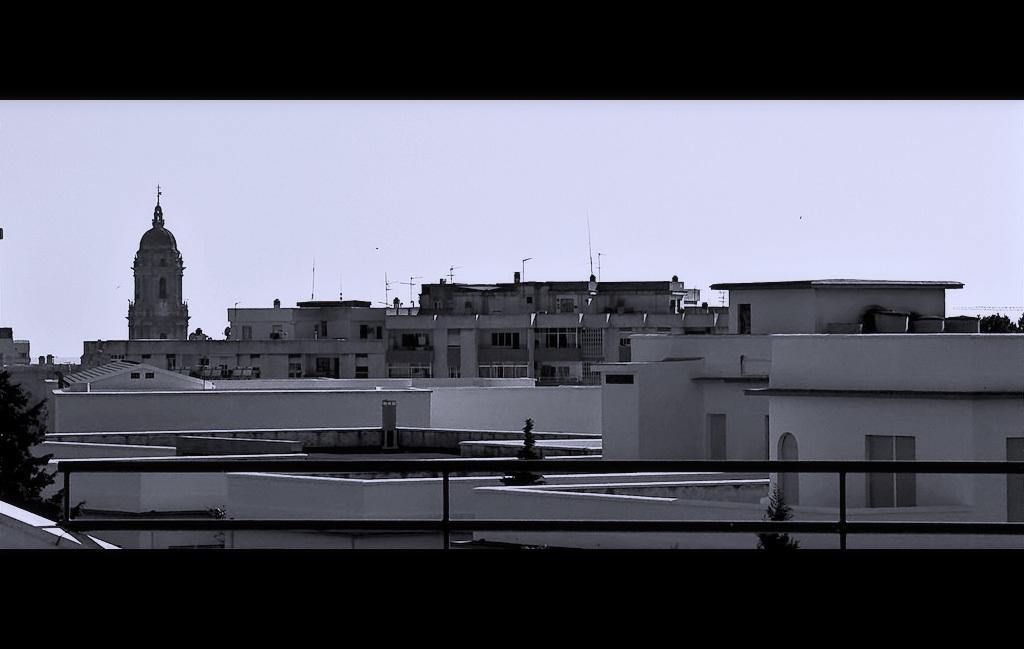Describe this image in one or two sentences. In the picture we can see a picture we can see buildings and a historical building beside it and in the background we can see a sky. 